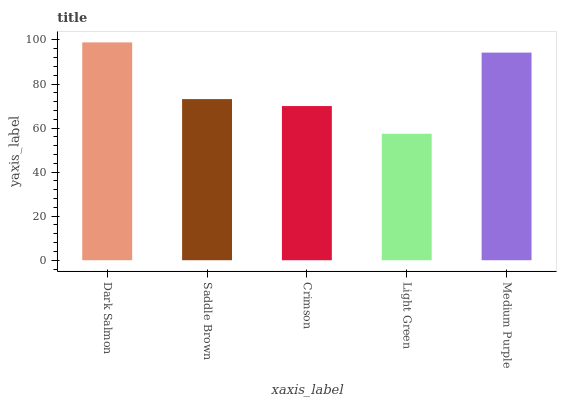Is Light Green the minimum?
Answer yes or no. Yes. Is Dark Salmon the maximum?
Answer yes or no. Yes. Is Saddle Brown the minimum?
Answer yes or no. No. Is Saddle Brown the maximum?
Answer yes or no. No. Is Dark Salmon greater than Saddle Brown?
Answer yes or no. Yes. Is Saddle Brown less than Dark Salmon?
Answer yes or no. Yes. Is Saddle Brown greater than Dark Salmon?
Answer yes or no. No. Is Dark Salmon less than Saddle Brown?
Answer yes or no. No. Is Saddle Brown the high median?
Answer yes or no. Yes. Is Saddle Brown the low median?
Answer yes or no. Yes. Is Crimson the high median?
Answer yes or no. No. Is Medium Purple the low median?
Answer yes or no. No. 